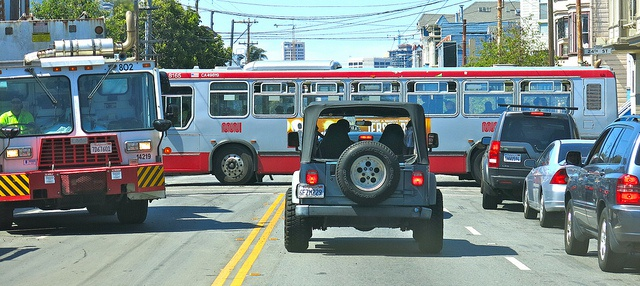Describe the objects in this image and their specific colors. I can see bus in gray, lightblue, and darkgray tones, truck in gray, blue, and black tones, car in gray, black, and blue tones, car in gray, lightblue, darkgray, and blue tones, and car in gray, blue, black, and darkblue tones in this image. 